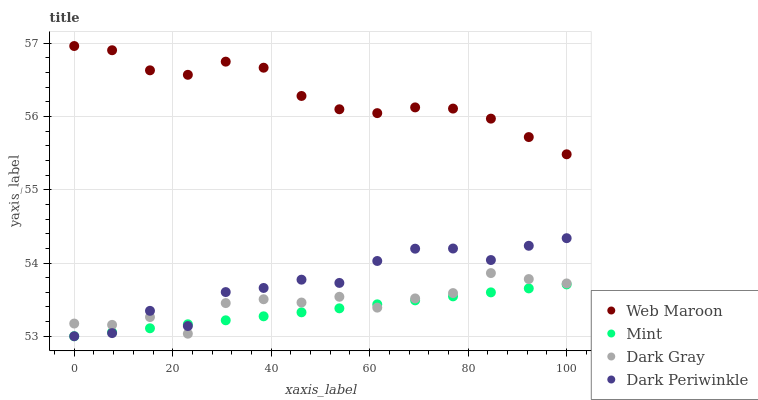Does Mint have the minimum area under the curve?
Answer yes or no. Yes. Does Web Maroon have the maximum area under the curve?
Answer yes or no. Yes. Does Web Maroon have the minimum area under the curve?
Answer yes or no. No. Does Mint have the maximum area under the curve?
Answer yes or no. No. Is Mint the smoothest?
Answer yes or no. Yes. Is Dark Periwinkle the roughest?
Answer yes or no. Yes. Is Web Maroon the smoothest?
Answer yes or no. No. Is Web Maroon the roughest?
Answer yes or no. No. Does Mint have the lowest value?
Answer yes or no. Yes. Does Web Maroon have the lowest value?
Answer yes or no. No. Does Web Maroon have the highest value?
Answer yes or no. Yes. Does Mint have the highest value?
Answer yes or no. No. Is Dark Gray less than Web Maroon?
Answer yes or no. Yes. Is Web Maroon greater than Mint?
Answer yes or no. Yes. Does Dark Gray intersect Mint?
Answer yes or no. Yes. Is Dark Gray less than Mint?
Answer yes or no. No. Is Dark Gray greater than Mint?
Answer yes or no. No. Does Dark Gray intersect Web Maroon?
Answer yes or no. No. 